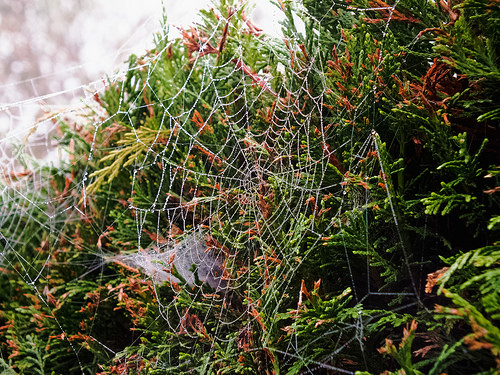<image>
Is there a spider web behind the smaller web? No. The spider web is not behind the smaller web. From this viewpoint, the spider web appears to be positioned elsewhere in the scene. 